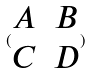<formula> <loc_0><loc_0><loc_500><loc_500>( \begin{matrix} A & B \\ C & D \end{matrix} )</formula> 